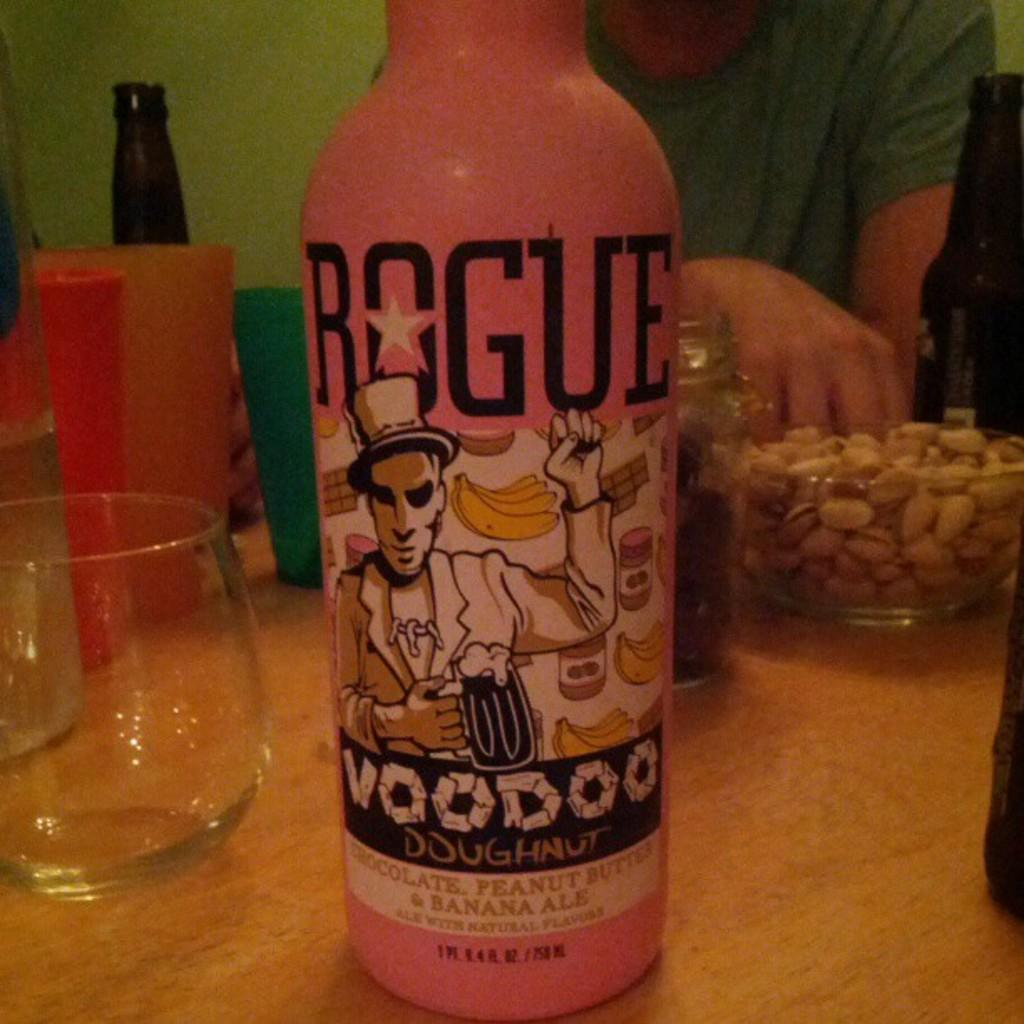Provide a one-sentence caption for the provided image. A hand reaches into a bowl of peanuts sitting on a table that also has a pink bottle of chcolate, peanut butter and banana ale on it. 